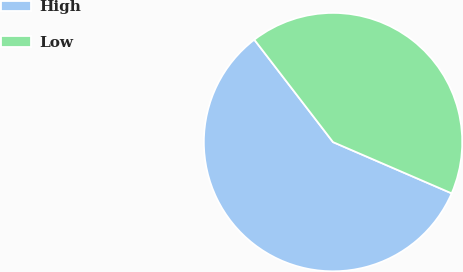Convert chart. <chart><loc_0><loc_0><loc_500><loc_500><pie_chart><fcel>High<fcel>Low<nl><fcel>58.08%<fcel>41.92%<nl></chart> 